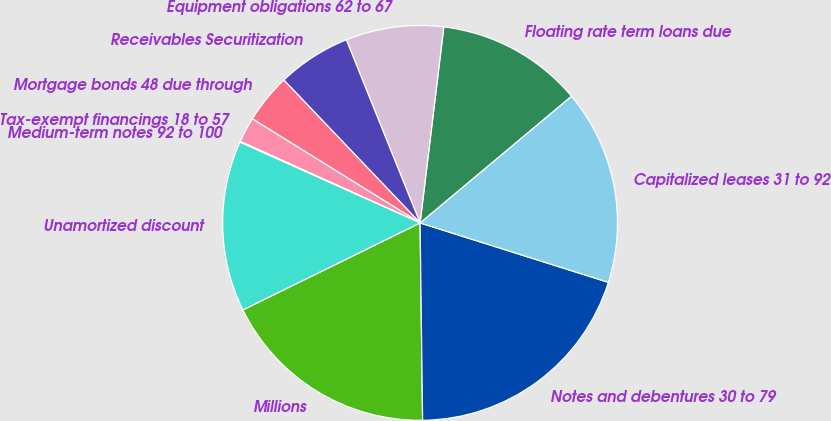Convert chart. <chart><loc_0><loc_0><loc_500><loc_500><pie_chart><fcel>Millions<fcel>Notes and debentures 30 to 79<fcel>Capitalized leases 31 to 92<fcel>Floating rate term loans due<fcel>Equipment obligations 62 to 67<fcel>Receivables Securitization<fcel>Mortgage bonds 48 due through<fcel>Tax-exempt financings 18 to 57<fcel>Medium-term notes 92 to 100<fcel>Unamortized discount<nl><fcel>17.94%<fcel>19.93%<fcel>15.96%<fcel>11.99%<fcel>8.01%<fcel>6.03%<fcel>4.04%<fcel>2.06%<fcel>0.07%<fcel>13.97%<nl></chart> 